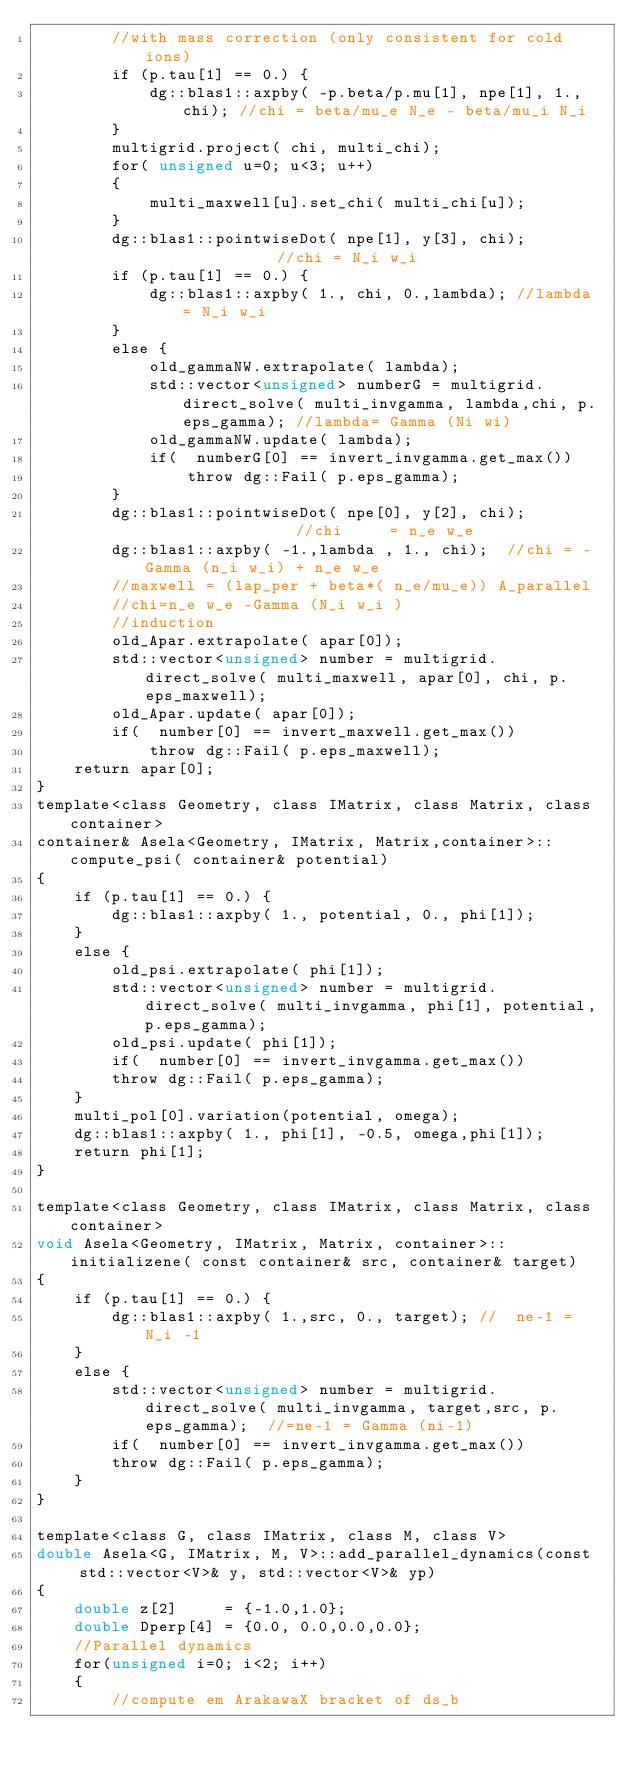Convert code to text. <code><loc_0><loc_0><loc_500><loc_500><_Cuda_>        //with mass correction (only consistent for cold ions)
        if (p.tau[1] == 0.) {
            dg::blas1::axpby( -p.beta/p.mu[1], npe[1], 1., chi); //chi = beta/mu_e N_e - beta/mu_i N_i 
        } 
        multigrid.project( chi, multi_chi);
        for( unsigned u=0; u<3; u++)
        {
            multi_maxwell[u].set_chi( multi_chi[u]);
        }
        dg::blas1::pointwiseDot( npe[1], y[3], chi);               //chi = N_i w_i
        if (p.tau[1] == 0.) {
            dg::blas1::axpby( 1., chi, 0.,lambda); //lambda = N_i w_i
        } 
        else {
            old_gammaNW.extrapolate( lambda);
            std::vector<unsigned> numberG = multigrid.direct_solve( multi_invgamma, lambda,chi, p.eps_gamma); //lambda= Gamma (Ni wi)
            old_gammaNW.update( lambda);
            if(  numberG[0] == invert_invgamma.get_max())
                throw dg::Fail( p.eps_gamma);
        }
        dg::blas1::pointwiseDot( npe[0], y[2], chi);                 //chi     = n_e w_e
        dg::blas1::axpby( -1.,lambda , 1., chi);  //chi = - Gamma (n_i w_i) + n_e w_e
        //maxwell = (lap_per + beta*( n_e/mu_e)) A_parallel 
        //chi=n_e w_e -Gamma (N_i w_i )
        //induction
        old_Apar.extrapolate( apar[0]);
        std::vector<unsigned> number = multigrid.direct_solve( multi_maxwell, apar[0], chi, p.eps_maxwell);
        old_Apar.update( apar[0]);
        if(  number[0] == invert_maxwell.get_max())
            throw dg::Fail( p.eps_maxwell);  
    return apar[0];
}
template<class Geometry, class IMatrix, class Matrix, class container>
container& Asela<Geometry, IMatrix, Matrix,container>::compute_psi( container& potential)
{
    if (p.tau[1] == 0.) {
        dg::blas1::axpby( 1., potential, 0., phi[1]); 
    } 
    else {
        old_psi.extrapolate( phi[1]);
        std::vector<unsigned> number = multigrid.direct_solve( multi_invgamma, phi[1], potential, p.eps_gamma);
        old_psi.update( phi[1]);
        if(  number[0] == invert_invgamma.get_max())
        throw dg::Fail( p.eps_gamma); 
    }
    multi_pol[0].variation(potential, omega); 
    dg::blas1::axpby( 1., phi[1], -0.5, omega,phi[1]);        
    return phi[1];  
}

template<class Geometry, class IMatrix, class Matrix, class container>
void Asela<Geometry, IMatrix, Matrix, container>::initializene( const container& src, container& target)
{ 
    if (p.tau[1] == 0.) {
        dg::blas1::axpby( 1.,src, 0., target); //  ne-1 = N_i -1
    } 
    else {
        std::vector<unsigned> number = multigrid.direct_solve( multi_invgamma, target,src, p.eps_gamma);  //=ne-1 = Gamma (ni-1)  
        if(  number[0] == invert_invgamma.get_max())
        throw dg::Fail( p.eps_gamma);
    }
}

template<class G, class IMatrix, class M, class V>
double Asela<G, IMatrix, M, V>::add_parallel_dynamics(const  std::vector<V>& y, std::vector<V>& yp)
{
    double z[2]     = {-1.0,1.0};
    double Dperp[4] = {0.0, 0.0,0.0,0.0};
    //Parallel dynamics
    for(unsigned i=0; i<2; i++)
    {
        //compute em ArakawaX bracket of ds_b</code> 